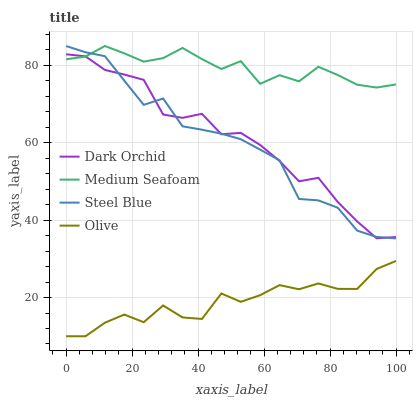Does Olive have the minimum area under the curve?
Answer yes or no. Yes. Does Medium Seafoam have the maximum area under the curve?
Answer yes or no. Yes. Does Dark Orchid have the minimum area under the curve?
Answer yes or no. No. Does Dark Orchid have the maximum area under the curve?
Answer yes or no. No. Is Medium Seafoam the smoothest?
Answer yes or no. Yes. Is Olive the roughest?
Answer yes or no. Yes. Is Dark Orchid the smoothest?
Answer yes or no. No. Is Dark Orchid the roughest?
Answer yes or no. No. Does Olive have the lowest value?
Answer yes or no. Yes. Does Dark Orchid have the lowest value?
Answer yes or no. No. Does Steel Blue have the highest value?
Answer yes or no. Yes. Does Dark Orchid have the highest value?
Answer yes or no. No. Is Olive less than Steel Blue?
Answer yes or no. Yes. Is Medium Seafoam greater than Olive?
Answer yes or no. Yes. Does Steel Blue intersect Dark Orchid?
Answer yes or no. Yes. Is Steel Blue less than Dark Orchid?
Answer yes or no. No. Is Steel Blue greater than Dark Orchid?
Answer yes or no. No. Does Olive intersect Steel Blue?
Answer yes or no. No. 